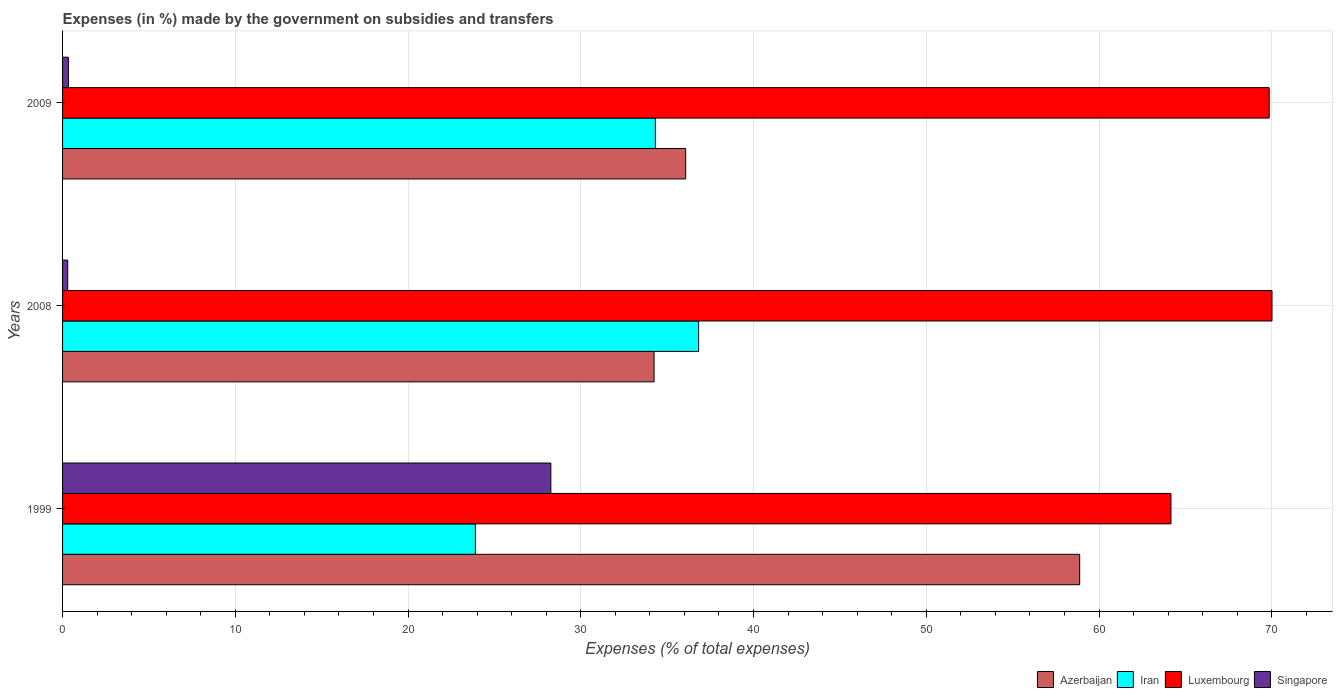How many different coloured bars are there?
Keep it short and to the point. 4. How many groups of bars are there?
Your answer should be compact. 3. In how many cases, is the number of bars for a given year not equal to the number of legend labels?
Keep it short and to the point. 0. What is the percentage of expenses made by the government on subsidies and transfers in Azerbaijan in 2008?
Provide a short and direct response. 34.24. Across all years, what is the maximum percentage of expenses made by the government on subsidies and transfers in Iran?
Your answer should be compact. 36.82. Across all years, what is the minimum percentage of expenses made by the government on subsidies and transfers in Iran?
Provide a succinct answer. 23.9. What is the total percentage of expenses made by the government on subsidies and transfers in Luxembourg in the graph?
Your answer should be compact. 204.03. What is the difference between the percentage of expenses made by the government on subsidies and transfers in Azerbaijan in 1999 and that in 2008?
Your response must be concise. 24.64. What is the difference between the percentage of expenses made by the government on subsidies and transfers in Luxembourg in 2009 and the percentage of expenses made by the government on subsidies and transfers in Azerbaijan in 1999?
Your answer should be compact. 10.97. What is the average percentage of expenses made by the government on subsidies and transfers in Azerbaijan per year?
Give a very brief answer. 43.06. In the year 2008, what is the difference between the percentage of expenses made by the government on subsidies and transfers in Luxembourg and percentage of expenses made by the government on subsidies and transfers in Singapore?
Ensure brevity in your answer.  69.71. What is the ratio of the percentage of expenses made by the government on subsidies and transfers in Singapore in 1999 to that in 2008?
Offer a very short reply. 94.38. Is the percentage of expenses made by the government on subsidies and transfers in Iran in 2008 less than that in 2009?
Offer a terse response. No. What is the difference between the highest and the second highest percentage of expenses made by the government on subsidies and transfers in Azerbaijan?
Offer a terse response. 22.81. What is the difference between the highest and the lowest percentage of expenses made by the government on subsidies and transfers in Singapore?
Your answer should be compact. 27.97. Is the sum of the percentage of expenses made by the government on subsidies and transfers in Singapore in 2008 and 2009 greater than the maximum percentage of expenses made by the government on subsidies and transfers in Iran across all years?
Offer a very short reply. No. What does the 2nd bar from the top in 2008 represents?
Provide a succinct answer. Luxembourg. What does the 4th bar from the bottom in 2008 represents?
Your response must be concise. Singapore. How many bars are there?
Keep it short and to the point. 12. Are all the bars in the graph horizontal?
Keep it short and to the point. Yes. Does the graph contain any zero values?
Keep it short and to the point. No. Where does the legend appear in the graph?
Keep it short and to the point. Bottom right. How many legend labels are there?
Your answer should be compact. 4. What is the title of the graph?
Ensure brevity in your answer.  Expenses (in %) made by the government on subsidies and transfers. What is the label or title of the X-axis?
Your response must be concise. Expenses (% of total expenses). What is the Expenses (% of total expenses) of Azerbaijan in 1999?
Your answer should be very brief. 58.88. What is the Expenses (% of total expenses) of Iran in 1999?
Your answer should be compact. 23.9. What is the Expenses (% of total expenses) of Luxembourg in 1999?
Offer a very short reply. 64.16. What is the Expenses (% of total expenses) in Singapore in 1999?
Ensure brevity in your answer.  28.27. What is the Expenses (% of total expenses) of Azerbaijan in 2008?
Keep it short and to the point. 34.24. What is the Expenses (% of total expenses) of Iran in 2008?
Ensure brevity in your answer.  36.82. What is the Expenses (% of total expenses) of Luxembourg in 2008?
Your answer should be compact. 70.01. What is the Expenses (% of total expenses) in Singapore in 2008?
Your answer should be very brief. 0.3. What is the Expenses (% of total expenses) in Azerbaijan in 2009?
Your response must be concise. 36.07. What is the Expenses (% of total expenses) of Iran in 2009?
Provide a succinct answer. 34.32. What is the Expenses (% of total expenses) in Luxembourg in 2009?
Ensure brevity in your answer.  69.85. What is the Expenses (% of total expenses) of Singapore in 2009?
Your answer should be compact. 0.34. Across all years, what is the maximum Expenses (% of total expenses) of Azerbaijan?
Make the answer very short. 58.88. Across all years, what is the maximum Expenses (% of total expenses) of Iran?
Keep it short and to the point. 36.82. Across all years, what is the maximum Expenses (% of total expenses) in Luxembourg?
Provide a short and direct response. 70.01. Across all years, what is the maximum Expenses (% of total expenses) of Singapore?
Ensure brevity in your answer.  28.27. Across all years, what is the minimum Expenses (% of total expenses) of Azerbaijan?
Make the answer very short. 34.24. Across all years, what is the minimum Expenses (% of total expenses) in Iran?
Offer a terse response. 23.9. Across all years, what is the minimum Expenses (% of total expenses) of Luxembourg?
Offer a very short reply. 64.16. Across all years, what is the minimum Expenses (% of total expenses) in Singapore?
Make the answer very short. 0.3. What is the total Expenses (% of total expenses) of Azerbaijan in the graph?
Make the answer very short. 129.19. What is the total Expenses (% of total expenses) of Iran in the graph?
Your response must be concise. 95.04. What is the total Expenses (% of total expenses) of Luxembourg in the graph?
Offer a very short reply. 204.03. What is the total Expenses (% of total expenses) of Singapore in the graph?
Your answer should be very brief. 28.91. What is the difference between the Expenses (% of total expenses) in Azerbaijan in 1999 and that in 2008?
Provide a short and direct response. 24.64. What is the difference between the Expenses (% of total expenses) in Iran in 1999 and that in 2008?
Your answer should be compact. -12.92. What is the difference between the Expenses (% of total expenses) in Luxembourg in 1999 and that in 2008?
Provide a short and direct response. -5.85. What is the difference between the Expenses (% of total expenses) in Singapore in 1999 and that in 2008?
Ensure brevity in your answer.  27.97. What is the difference between the Expenses (% of total expenses) in Azerbaijan in 1999 and that in 2009?
Your answer should be compact. 22.81. What is the difference between the Expenses (% of total expenses) in Iran in 1999 and that in 2009?
Offer a very short reply. -10.42. What is the difference between the Expenses (% of total expenses) in Luxembourg in 1999 and that in 2009?
Offer a very short reply. -5.69. What is the difference between the Expenses (% of total expenses) in Singapore in 1999 and that in 2009?
Offer a terse response. 27.93. What is the difference between the Expenses (% of total expenses) in Azerbaijan in 2008 and that in 2009?
Provide a succinct answer. -1.83. What is the difference between the Expenses (% of total expenses) in Iran in 2008 and that in 2009?
Your response must be concise. 2.5. What is the difference between the Expenses (% of total expenses) of Luxembourg in 2008 and that in 2009?
Give a very brief answer. 0.16. What is the difference between the Expenses (% of total expenses) in Singapore in 2008 and that in 2009?
Provide a short and direct response. -0.04. What is the difference between the Expenses (% of total expenses) of Azerbaijan in 1999 and the Expenses (% of total expenses) of Iran in 2008?
Your response must be concise. 22.06. What is the difference between the Expenses (% of total expenses) in Azerbaijan in 1999 and the Expenses (% of total expenses) in Luxembourg in 2008?
Provide a short and direct response. -11.13. What is the difference between the Expenses (% of total expenses) of Azerbaijan in 1999 and the Expenses (% of total expenses) of Singapore in 2008?
Offer a very short reply. 58.58. What is the difference between the Expenses (% of total expenses) in Iran in 1999 and the Expenses (% of total expenses) in Luxembourg in 2008?
Your response must be concise. -46.12. What is the difference between the Expenses (% of total expenses) of Iran in 1999 and the Expenses (% of total expenses) of Singapore in 2008?
Make the answer very short. 23.6. What is the difference between the Expenses (% of total expenses) of Luxembourg in 1999 and the Expenses (% of total expenses) of Singapore in 2008?
Offer a very short reply. 63.86. What is the difference between the Expenses (% of total expenses) in Azerbaijan in 1999 and the Expenses (% of total expenses) in Iran in 2009?
Offer a terse response. 24.56. What is the difference between the Expenses (% of total expenses) in Azerbaijan in 1999 and the Expenses (% of total expenses) in Luxembourg in 2009?
Provide a short and direct response. -10.97. What is the difference between the Expenses (% of total expenses) of Azerbaijan in 1999 and the Expenses (% of total expenses) of Singapore in 2009?
Give a very brief answer. 58.54. What is the difference between the Expenses (% of total expenses) of Iran in 1999 and the Expenses (% of total expenses) of Luxembourg in 2009?
Provide a short and direct response. -45.95. What is the difference between the Expenses (% of total expenses) of Iran in 1999 and the Expenses (% of total expenses) of Singapore in 2009?
Make the answer very short. 23.56. What is the difference between the Expenses (% of total expenses) in Luxembourg in 1999 and the Expenses (% of total expenses) in Singapore in 2009?
Keep it short and to the point. 63.82. What is the difference between the Expenses (% of total expenses) in Azerbaijan in 2008 and the Expenses (% of total expenses) in Iran in 2009?
Give a very brief answer. -0.07. What is the difference between the Expenses (% of total expenses) of Azerbaijan in 2008 and the Expenses (% of total expenses) of Luxembourg in 2009?
Ensure brevity in your answer.  -35.61. What is the difference between the Expenses (% of total expenses) of Azerbaijan in 2008 and the Expenses (% of total expenses) of Singapore in 2009?
Offer a terse response. 33.9. What is the difference between the Expenses (% of total expenses) of Iran in 2008 and the Expenses (% of total expenses) of Luxembourg in 2009?
Your response must be concise. -33.03. What is the difference between the Expenses (% of total expenses) of Iran in 2008 and the Expenses (% of total expenses) of Singapore in 2009?
Make the answer very short. 36.48. What is the difference between the Expenses (% of total expenses) in Luxembourg in 2008 and the Expenses (% of total expenses) in Singapore in 2009?
Ensure brevity in your answer.  69.68. What is the average Expenses (% of total expenses) in Azerbaijan per year?
Provide a short and direct response. 43.06. What is the average Expenses (% of total expenses) of Iran per year?
Keep it short and to the point. 31.68. What is the average Expenses (% of total expenses) of Luxembourg per year?
Give a very brief answer. 68.01. What is the average Expenses (% of total expenses) of Singapore per year?
Provide a succinct answer. 9.64. In the year 1999, what is the difference between the Expenses (% of total expenses) in Azerbaijan and Expenses (% of total expenses) in Iran?
Your response must be concise. 34.98. In the year 1999, what is the difference between the Expenses (% of total expenses) of Azerbaijan and Expenses (% of total expenses) of Luxembourg?
Make the answer very short. -5.28. In the year 1999, what is the difference between the Expenses (% of total expenses) in Azerbaijan and Expenses (% of total expenses) in Singapore?
Your answer should be compact. 30.61. In the year 1999, what is the difference between the Expenses (% of total expenses) of Iran and Expenses (% of total expenses) of Luxembourg?
Offer a very short reply. -40.27. In the year 1999, what is the difference between the Expenses (% of total expenses) of Iran and Expenses (% of total expenses) of Singapore?
Your answer should be very brief. -4.37. In the year 1999, what is the difference between the Expenses (% of total expenses) of Luxembourg and Expenses (% of total expenses) of Singapore?
Your response must be concise. 35.9. In the year 2008, what is the difference between the Expenses (% of total expenses) of Azerbaijan and Expenses (% of total expenses) of Iran?
Keep it short and to the point. -2.58. In the year 2008, what is the difference between the Expenses (% of total expenses) in Azerbaijan and Expenses (% of total expenses) in Luxembourg?
Your response must be concise. -35.77. In the year 2008, what is the difference between the Expenses (% of total expenses) in Azerbaijan and Expenses (% of total expenses) in Singapore?
Offer a terse response. 33.94. In the year 2008, what is the difference between the Expenses (% of total expenses) of Iran and Expenses (% of total expenses) of Luxembourg?
Provide a short and direct response. -33.19. In the year 2008, what is the difference between the Expenses (% of total expenses) of Iran and Expenses (% of total expenses) of Singapore?
Provide a succinct answer. 36.52. In the year 2008, what is the difference between the Expenses (% of total expenses) of Luxembourg and Expenses (% of total expenses) of Singapore?
Offer a terse response. 69.72. In the year 2009, what is the difference between the Expenses (% of total expenses) in Azerbaijan and Expenses (% of total expenses) in Iran?
Your response must be concise. 1.75. In the year 2009, what is the difference between the Expenses (% of total expenses) in Azerbaijan and Expenses (% of total expenses) in Luxembourg?
Give a very brief answer. -33.78. In the year 2009, what is the difference between the Expenses (% of total expenses) of Azerbaijan and Expenses (% of total expenses) of Singapore?
Offer a terse response. 35.73. In the year 2009, what is the difference between the Expenses (% of total expenses) of Iran and Expenses (% of total expenses) of Luxembourg?
Make the answer very short. -35.54. In the year 2009, what is the difference between the Expenses (% of total expenses) in Iran and Expenses (% of total expenses) in Singapore?
Provide a short and direct response. 33.98. In the year 2009, what is the difference between the Expenses (% of total expenses) of Luxembourg and Expenses (% of total expenses) of Singapore?
Provide a succinct answer. 69.51. What is the ratio of the Expenses (% of total expenses) in Azerbaijan in 1999 to that in 2008?
Offer a very short reply. 1.72. What is the ratio of the Expenses (% of total expenses) in Iran in 1999 to that in 2008?
Provide a succinct answer. 0.65. What is the ratio of the Expenses (% of total expenses) of Luxembourg in 1999 to that in 2008?
Provide a succinct answer. 0.92. What is the ratio of the Expenses (% of total expenses) of Singapore in 1999 to that in 2008?
Your answer should be compact. 94.38. What is the ratio of the Expenses (% of total expenses) of Azerbaijan in 1999 to that in 2009?
Provide a succinct answer. 1.63. What is the ratio of the Expenses (% of total expenses) of Iran in 1999 to that in 2009?
Offer a terse response. 0.7. What is the ratio of the Expenses (% of total expenses) of Luxembourg in 1999 to that in 2009?
Offer a very short reply. 0.92. What is the ratio of the Expenses (% of total expenses) in Singapore in 1999 to that in 2009?
Your response must be concise. 83.34. What is the ratio of the Expenses (% of total expenses) in Azerbaijan in 2008 to that in 2009?
Offer a very short reply. 0.95. What is the ratio of the Expenses (% of total expenses) in Iran in 2008 to that in 2009?
Provide a short and direct response. 1.07. What is the ratio of the Expenses (% of total expenses) in Singapore in 2008 to that in 2009?
Your answer should be compact. 0.88. What is the difference between the highest and the second highest Expenses (% of total expenses) in Azerbaijan?
Provide a short and direct response. 22.81. What is the difference between the highest and the second highest Expenses (% of total expenses) of Iran?
Keep it short and to the point. 2.5. What is the difference between the highest and the second highest Expenses (% of total expenses) in Luxembourg?
Give a very brief answer. 0.16. What is the difference between the highest and the second highest Expenses (% of total expenses) in Singapore?
Your response must be concise. 27.93. What is the difference between the highest and the lowest Expenses (% of total expenses) of Azerbaijan?
Make the answer very short. 24.64. What is the difference between the highest and the lowest Expenses (% of total expenses) in Iran?
Provide a succinct answer. 12.92. What is the difference between the highest and the lowest Expenses (% of total expenses) in Luxembourg?
Offer a terse response. 5.85. What is the difference between the highest and the lowest Expenses (% of total expenses) in Singapore?
Keep it short and to the point. 27.97. 